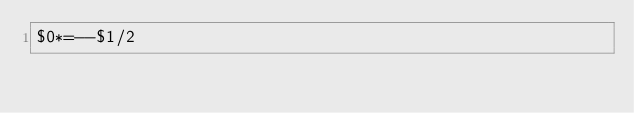<code> <loc_0><loc_0><loc_500><loc_500><_Awk_>$0*=--$1/2</code> 